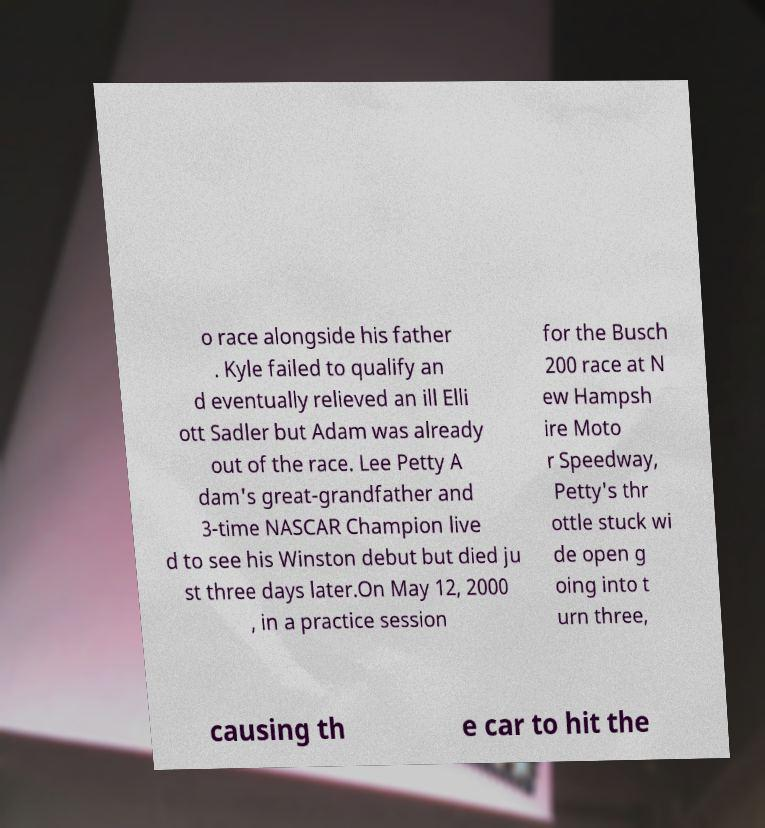Could you assist in decoding the text presented in this image and type it out clearly? o race alongside his father . Kyle failed to qualify an d eventually relieved an ill Elli ott Sadler but Adam was already out of the race. Lee Petty A dam's great-grandfather and 3-time NASCAR Champion live d to see his Winston debut but died ju st three days later.On May 12, 2000 , in a practice session for the Busch 200 race at N ew Hampsh ire Moto r Speedway, Petty's thr ottle stuck wi de open g oing into t urn three, causing th e car to hit the 